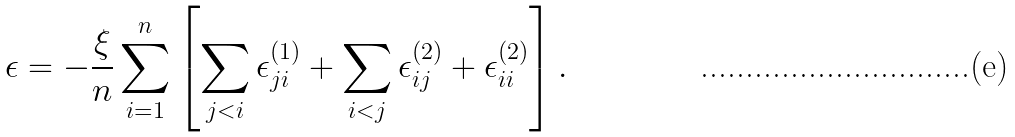<formula> <loc_0><loc_0><loc_500><loc_500>\epsilon = - \frac { \xi } { n } \sum _ { i = 1 } ^ { n } \left [ \sum _ { j < i } \epsilon ^ { ( 1 ) } _ { j i } + \sum _ { i < j } \epsilon ^ { ( 2 ) } _ { i j } + \epsilon ^ { ( 2 ) } _ { i i } \right ] .</formula> 